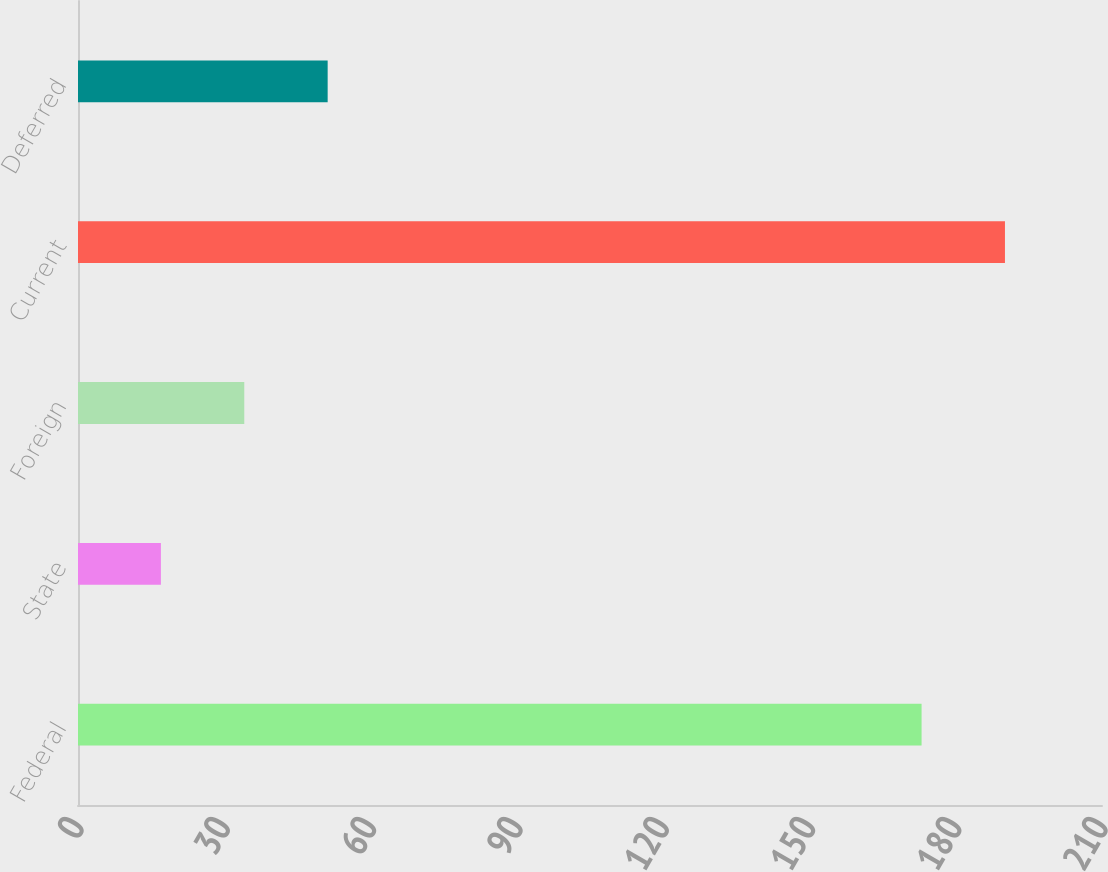Convert chart to OTSL. <chart><loc_0><loc_0><loc_500><loc_500><bar_chart><fcel>Federal<fcel>State<fcel>Foreign<fcel>Current<fcel>Deferred<nl><fcel>173<fcel>17<fcel>34.1<fcel>190.1<fcel>51.2<nl></chart> 